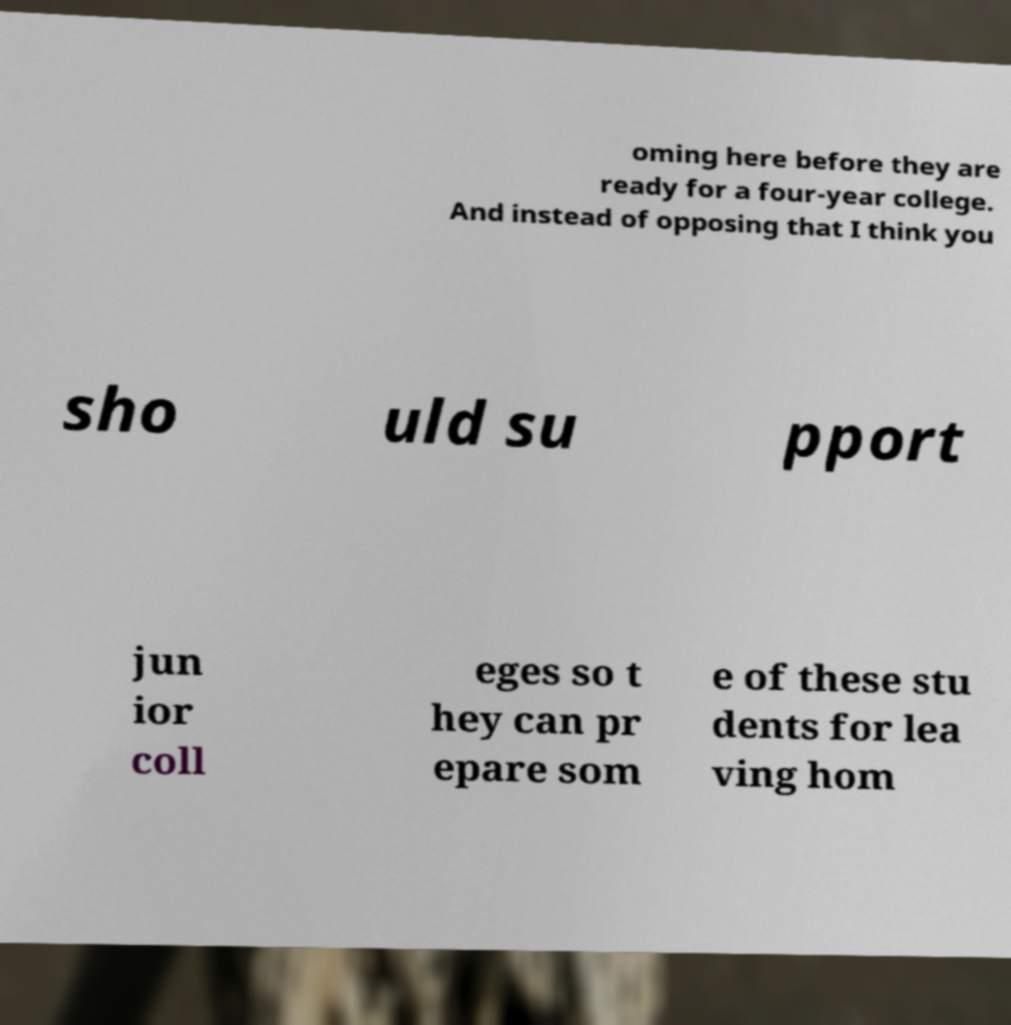What messages or text are displayed in this image? I need them in a readable, typed format. oming here before they are ready for a four-year college. And instead of opposing that I think you sho uld su pport jun ior coll eges so t hey can pr epare som e of these stu dents for lea ving hom 